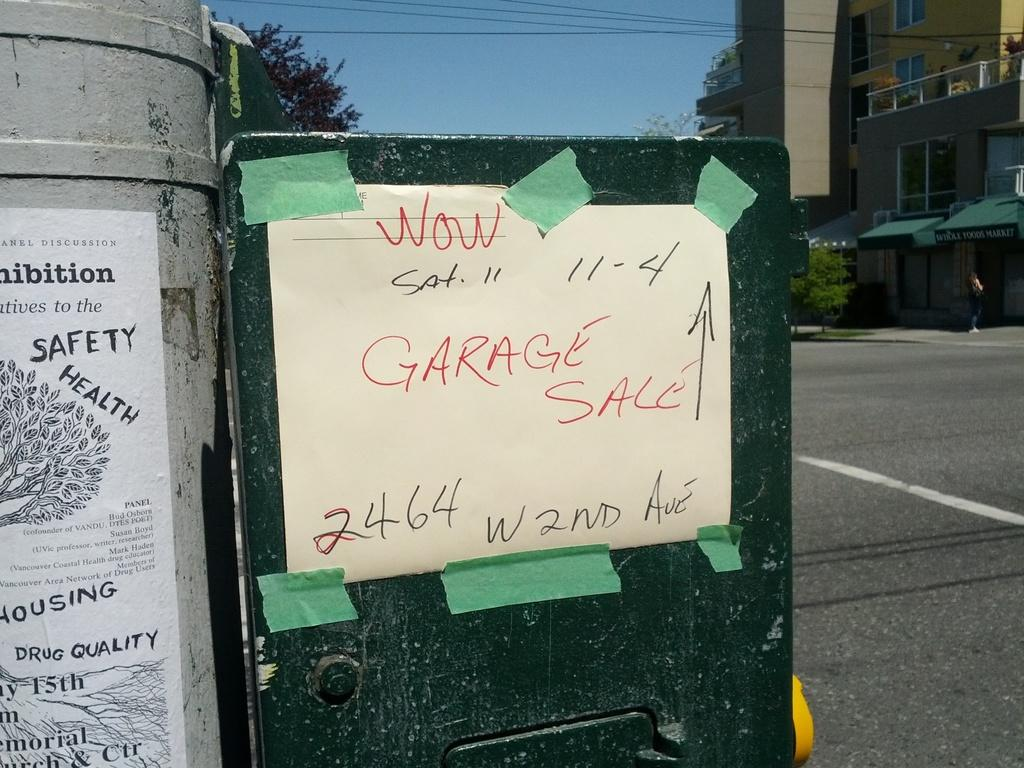What is located inside the cement pole in the image? There is a garbage can inside a cement pole in the image. What can be seen on the cement pole besides the garbage can? There is a notice on the cement pole. What is visible on the right side of the image? There is a road, trees, and a building on the right side of the image. What word is the woman using to express her comfort in the image? There is no woman present in the image, and therefore no such interaction can be observed. 